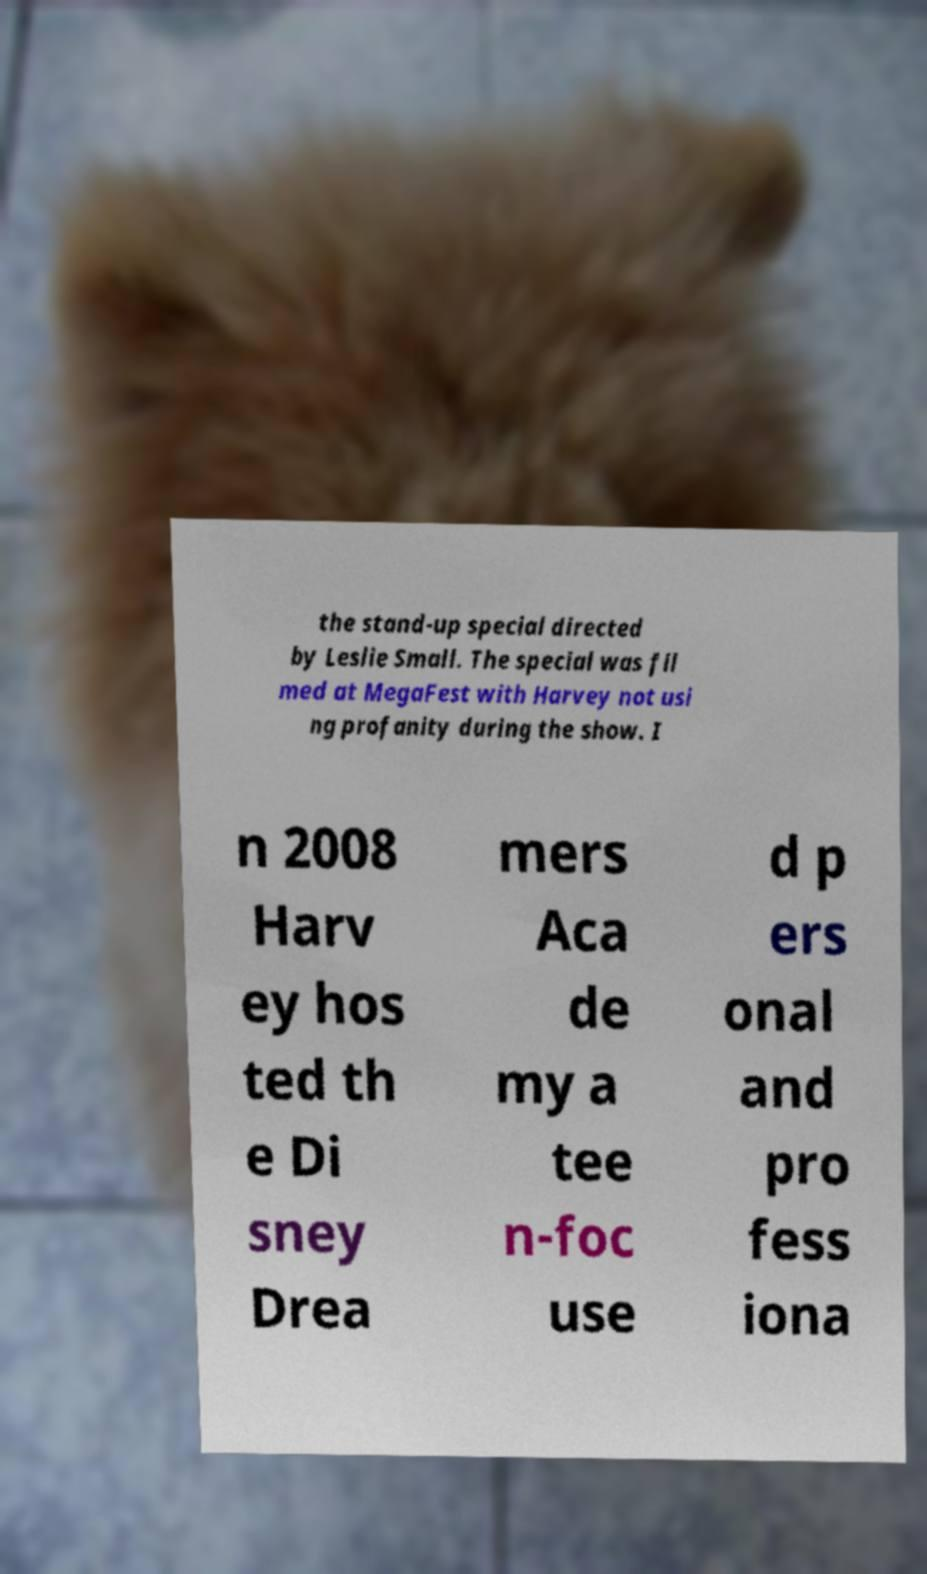There's text embedded in this image that I need extracted. Can you transcribe it verbatim? the stand-up special directed by Leslie Small. The special was fil med at MegaFest with Harvey not usi ng profanity during the show. I n 2008 Harv ey hos ted th e Di sney Drea mers Aca de my a tee n-foc use d p ers onal and pro fess iona 